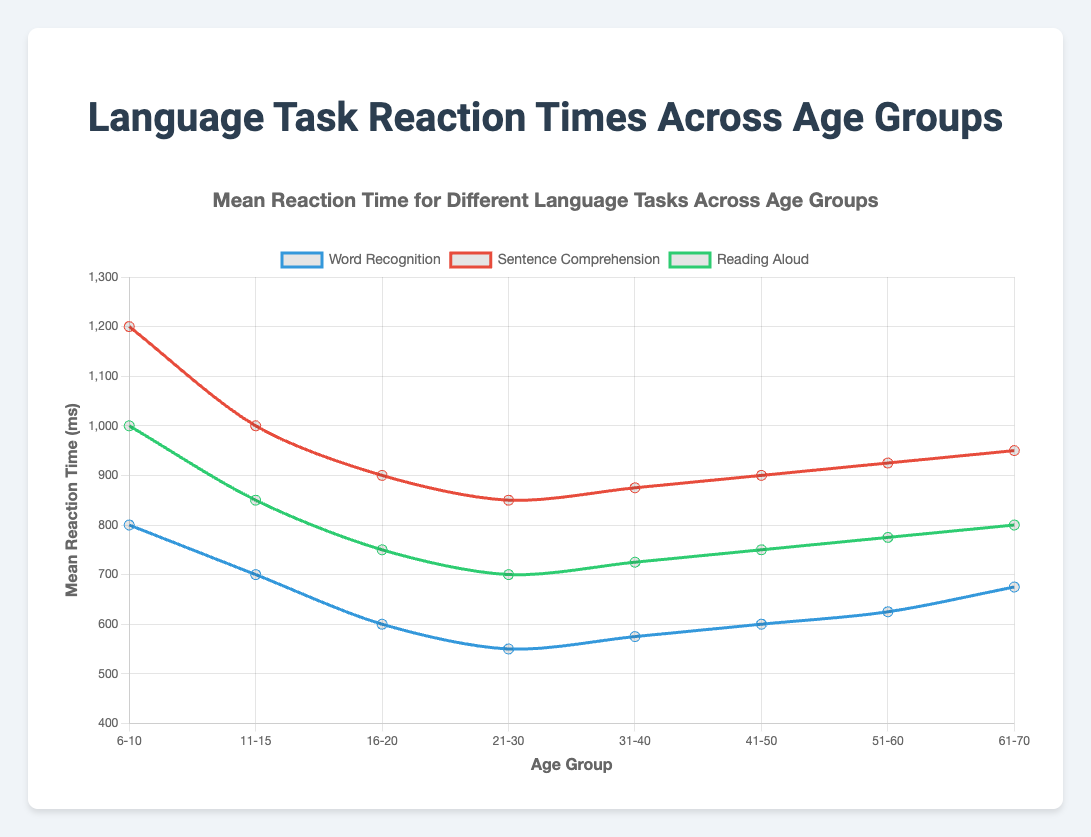What is the mean reaction time for Sentence Comprehension in the age group 21-30? Select the 'Sentence Comprehension' line in the chart. Identify the mean reaction time point for the age group '21-30'.
Answer: 850 ms Which language task shows the greatest decrease in mean reaction time from the age group 6-10 to 21-30? Compare the differences in mean reaction times between 6-10 and 21-30 for each task type: Word Recognition (800 to 550), Sentence Comprehension (1200 to 850), and Reading Aloud (1000 to 700). Word Recognition has a decrease of 250 ms, Sentence Comprehension 350 ms, and Reading Aloud 300 ms.
Answer: Sentence Comprehension Across all age groups, which language task consistently has the lowest mean reaction time? Observe the chart and find the task type that continuously has the lowest mean reaction time for all age groups: Word Recognition, Sentence Comprehension, and Reading Aloud.
Answer: Word Recognition For the age group 11-15, what is the difference in mean reaction time between Word Recognition and Reading Aloud? Identify the mean reaction times for Word Recognition (700 ms) and Reading Aloud (850 ms) in the age group 11-15. Calculate the difference: 850 - 700.
Answer: 150 ms Which age group has the highest standard deviation in reaction time for Sentence Comprehension? Select the 'Sentence Comprehension' line in the chart. Compare the standard deviations: 6-10 (280 ms), 11-15 (220 ms), 16-20 (200 ms), 21-30 (190 ms), 31-40 (195 ms), 41-50 (200 ms), 51-60 (205 ms), 61-70 (210 ms).
Answer: 6-10 As age increases from 11-15 to 21-30, does the mean reaction time for Reading Aloud increase, decrease, or stay the same? Observe the points for the age groups 11-15 (850 ms), 16-20 (750 ms), and 21-30 (700 ms) on the Reading Aloud line.
Answer: Decrease What's the average mean reaction time for all language tasks in the age group 51-60? Calculate the average of three mean reaction times: Word Recognition (625 ms), Sentence Comprehension (925 ms), and Reading Aloud (775 ms). (625 + 925 + 775) / 3 = 2250 / 3.
Answer: 750 ms In which age group does the mean reaction time for Word Recognition increase after decreasing from younger to older groups? Follow the 'Word Recognition' line across all age groups (6-10: 800, 11-15: 700, 16-20: 600, 21-30: 550, 31-40: 575, 41-50: 600, 51-60: 625, 61-70: 675) and observe where it increases after initially decreasing.
Answer: 31-40 